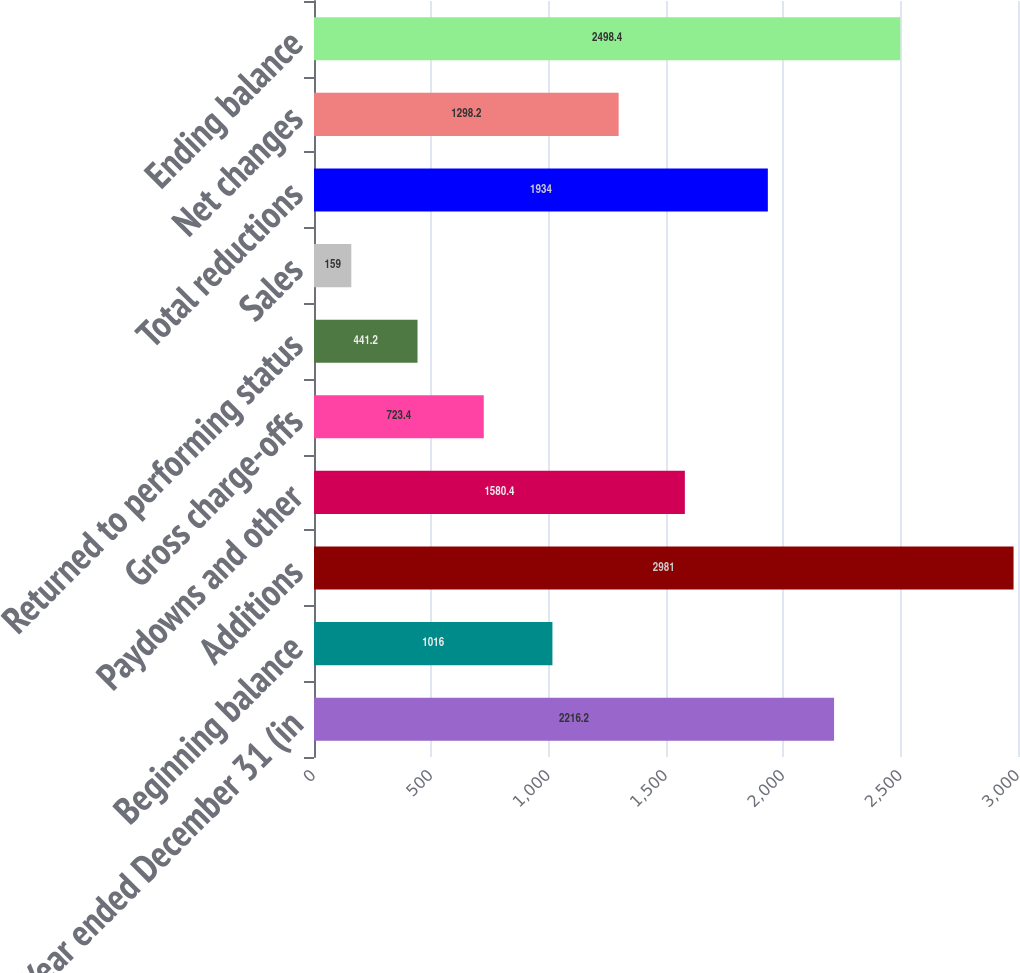<chart> <loc_0><loc_0><loc_500><loc_500><bar_chart><fcel>Year ended December 31 (in<fcel>Beginning balance<fcel>Additions<fcel>Paydowns and other<fcel>Gross charge-offs<fcel>Returned to performing status<fcel>Sales<fcel>Total reductions<fcel>Net changes<fcel>Ending balance<nl><fcel>2216.2<fcel>1016<fcel>2981<fcel>1580.4<fcel>723.4<fcel>441.2<fcel>159<fcel>1934<fcel>1298.2<fcel>2498.4<nl></chart> 